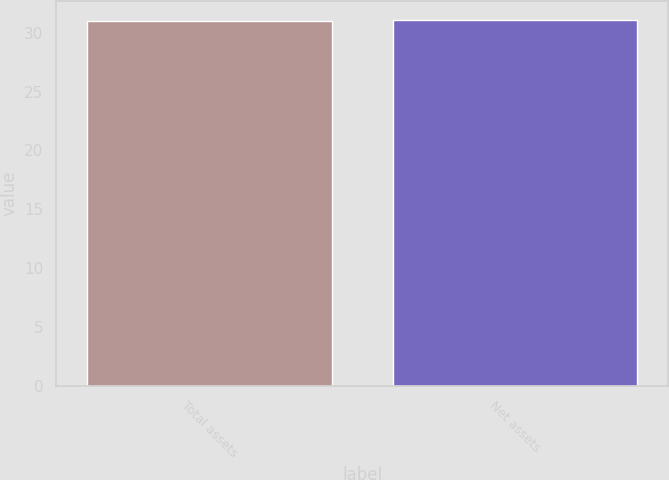Convert chart. <chart><loc_0><loc_0><loc_500><loc_500><bar_chart><fcel>Total assets<fcel>Net assets<nl><fcel>31<fcel>31.1<nl></chart> 